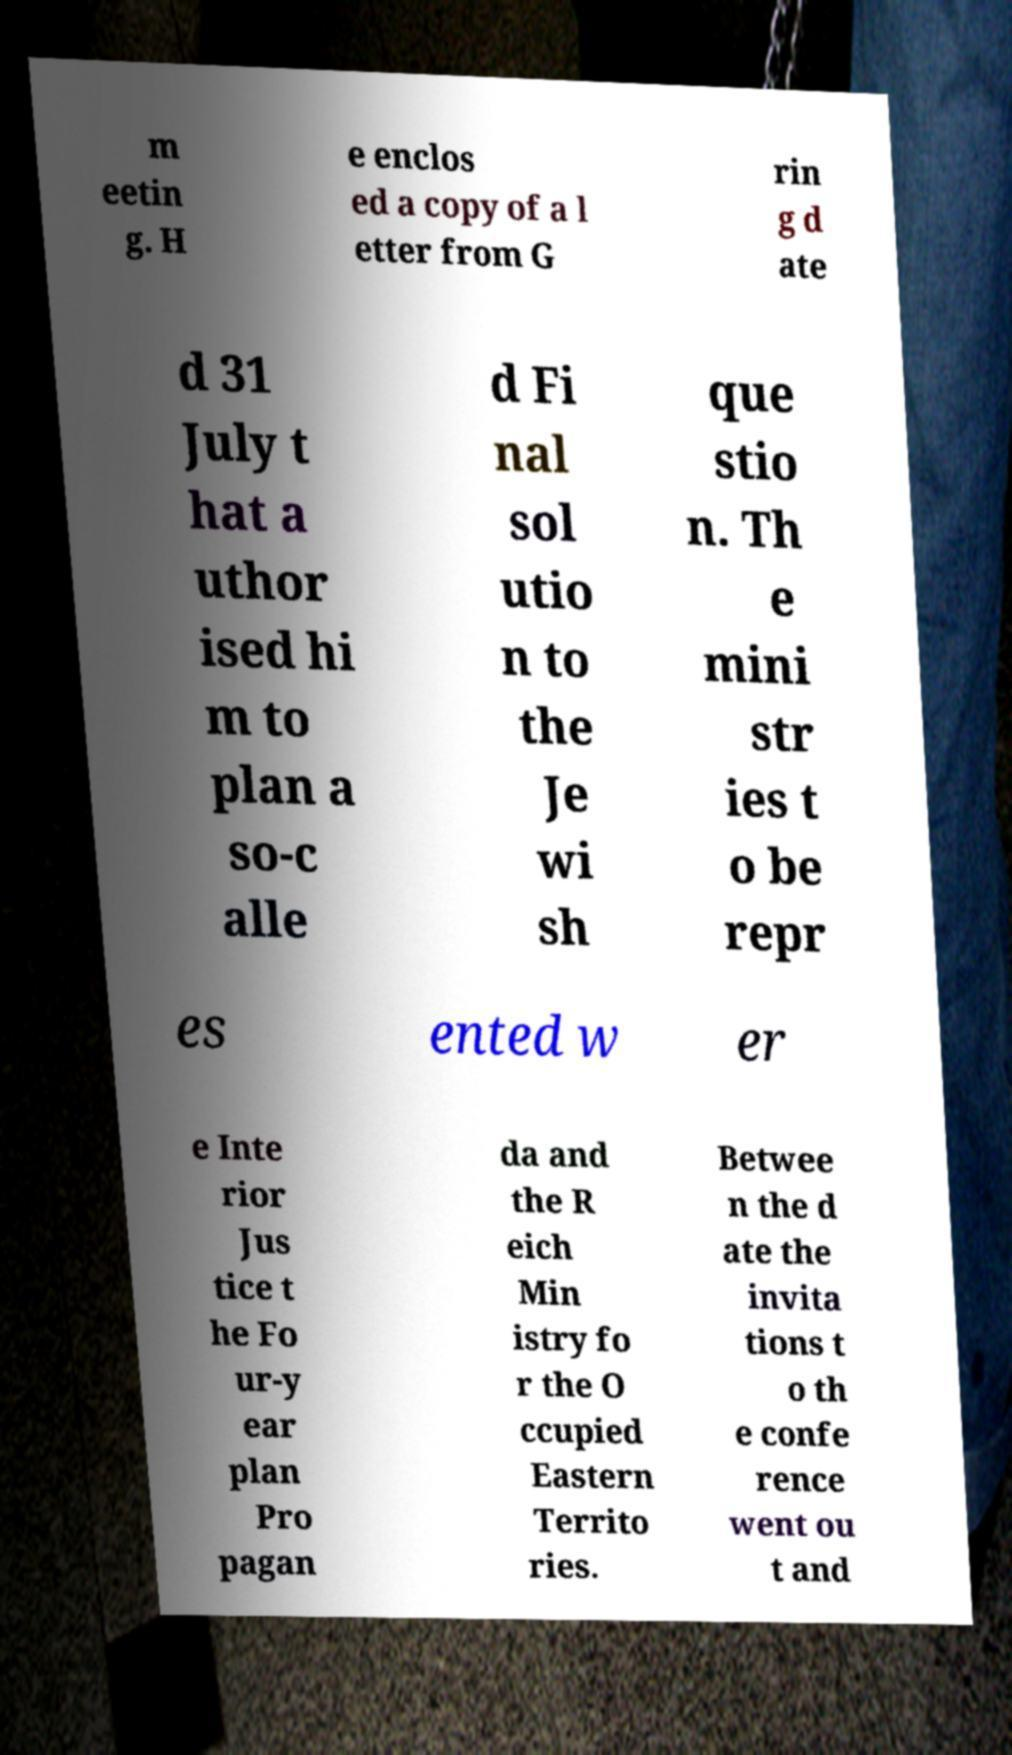I need the written content from this picture converted into text. Can you do that? m eetin g. H e enclos ed a copy of a l etter from G rin g d ate d 31 July t hat a uthor ised hi m to plan a so-c alle d Fi nal sol utio n to the Je wi sh que stio n. Th e mini str ies t o be repr es ented w er e Inte rior Jus tice t he Fo ur-y ear plan Pro pagan da and the R eich Min istry fo r the O ccupied Eastern Territo ries. Betwee n the d ate the invita tions t o th e confe rence went ou t and 